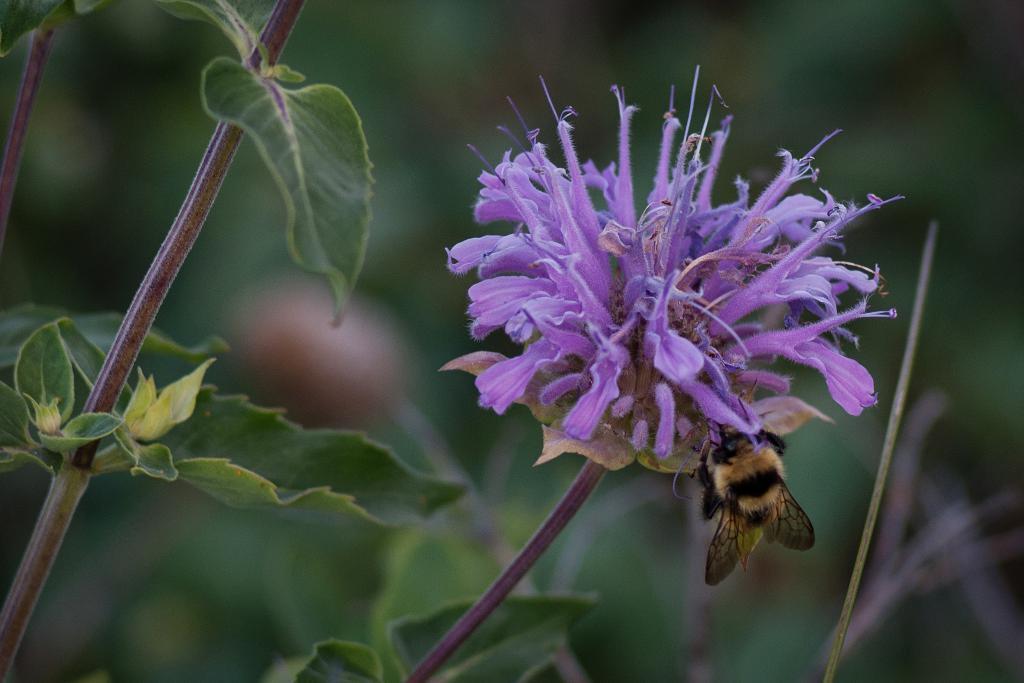Can you describe this image briefly? In this image I can see on there is a honey bee on the brinjal color flower. On the left side there is a plant. 